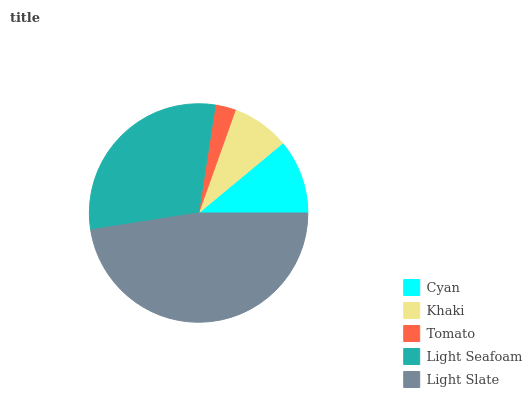Is Tomato the minimum?
Answer yes or no. Yes. Is Light Slate the maximum?
Answer yes or no. Yes. Is Khaki the minimum?
Answer yes or no. No. Is Khaki the maximum?
Answer yes or no. No. Is Cyan greater than Khaki?
Answer yes or no. Yes. Is Khaki less than Cyan?
Answer yes or no. Yes. Is Khaki greater than Cyan?
Answer yes or no. No. Is Cyan less than Khaki?
Answer yes or no. No. Is Cyan the high median?
Answer yes or no. Yes. Is Cyan the low median?
Answer yes or no. Yes. Is Light Seafoam the high median?
Answer yes or no. No. Is Tomato the low median?
Answer yes or no. No. 